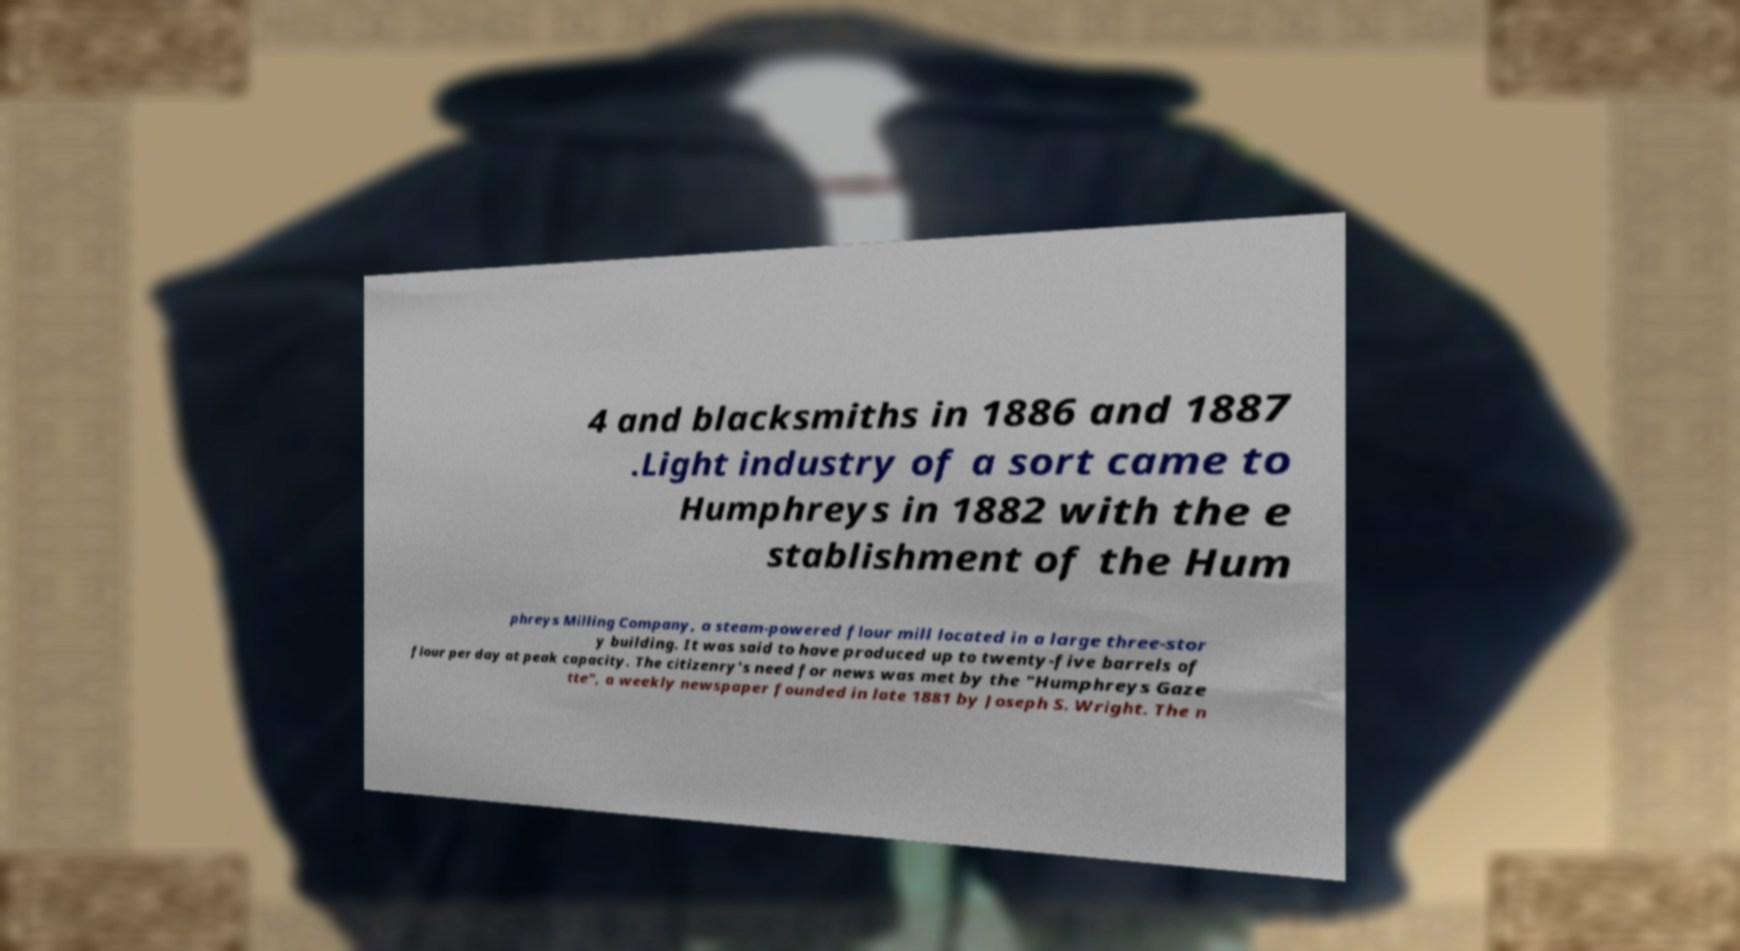Can you read and provide the text displayed in the image?This photo seems to have some interesting text. Can you extract and type it out for me? 4 and blacksmiths in 1886 and 1887 .Light industry of a sort came to Humphreys in 1882 with the e stablishment of the Hum phreys Milling Company, a steam-powered flour mill located in a large three-stor y building. It was said to have produced up to twenty-five barrels of flour per day at peak capacity. The citizenry's need for news was met by the "Humphreys Gaze tte", a weekly newspaper founded in late 1881 by Joseph S. Wright. The n 